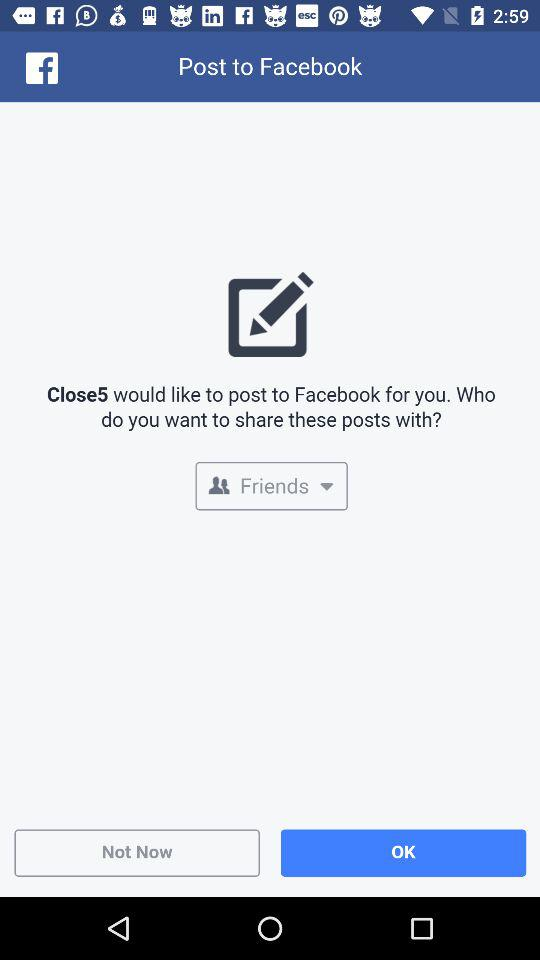Which application will receive your public profile and email address?
When the provided information is insufficient, respond with <no answer>. <no answer> 